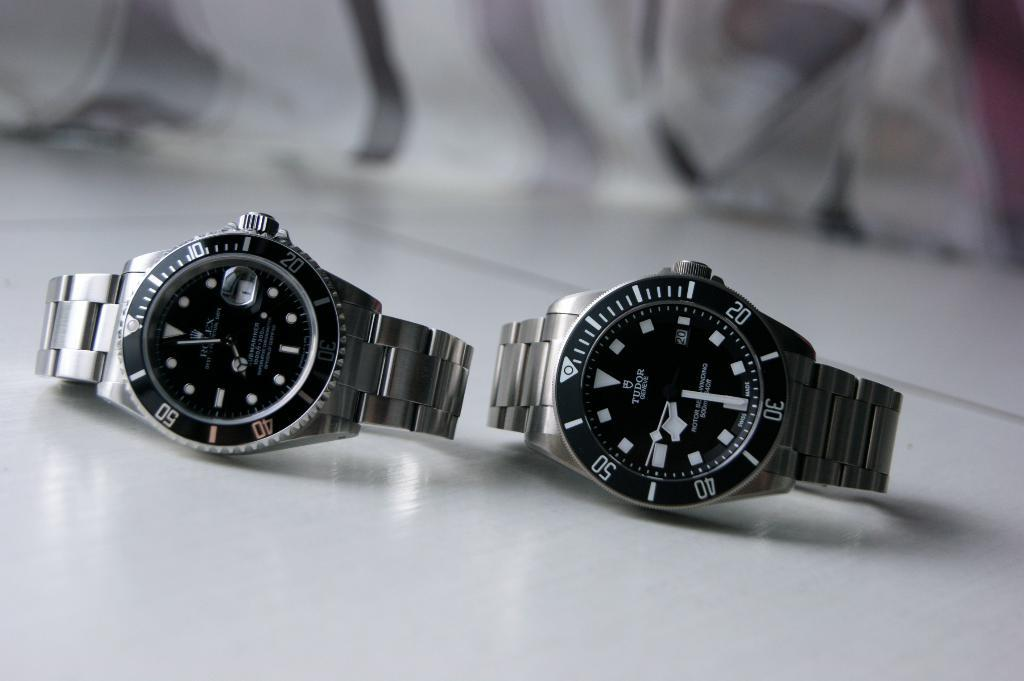Provide a one-sentence caption for the provided image. Silver and black watch which says TUDOR on it. 